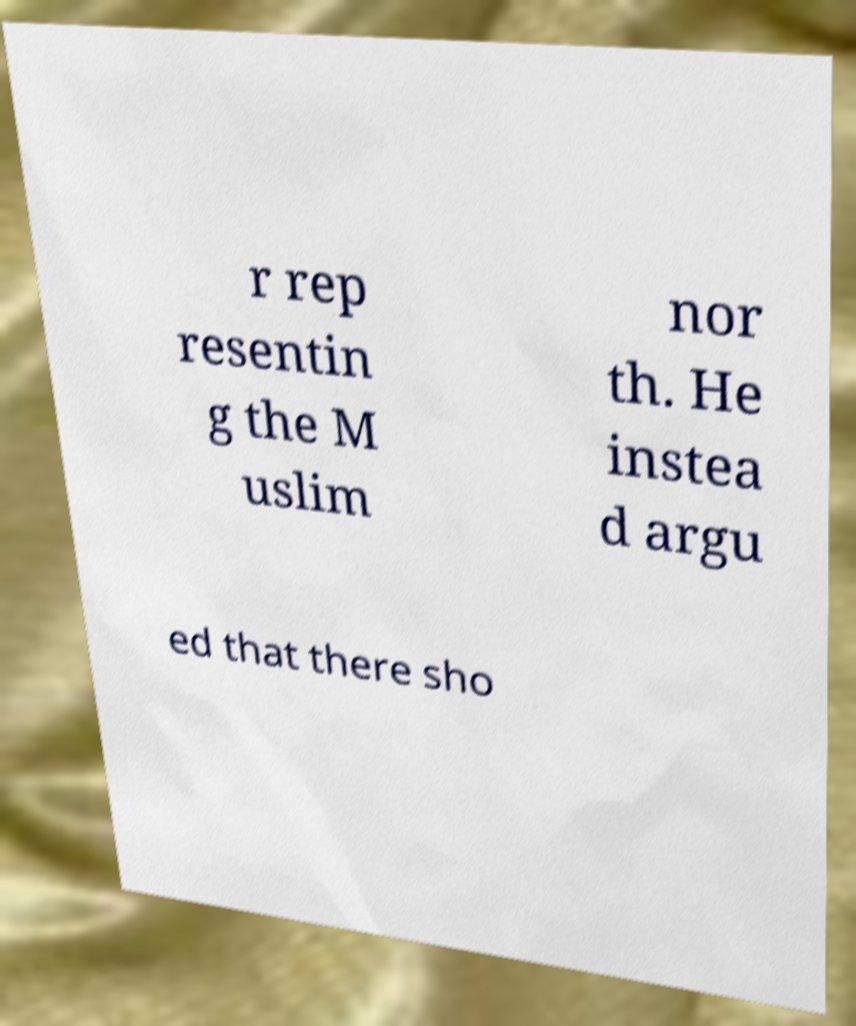What messages or text are displayed in this image? I need them in a readable, typed format. r rep resentin g the M uslim nor th. He instea d argu ed that there sho 